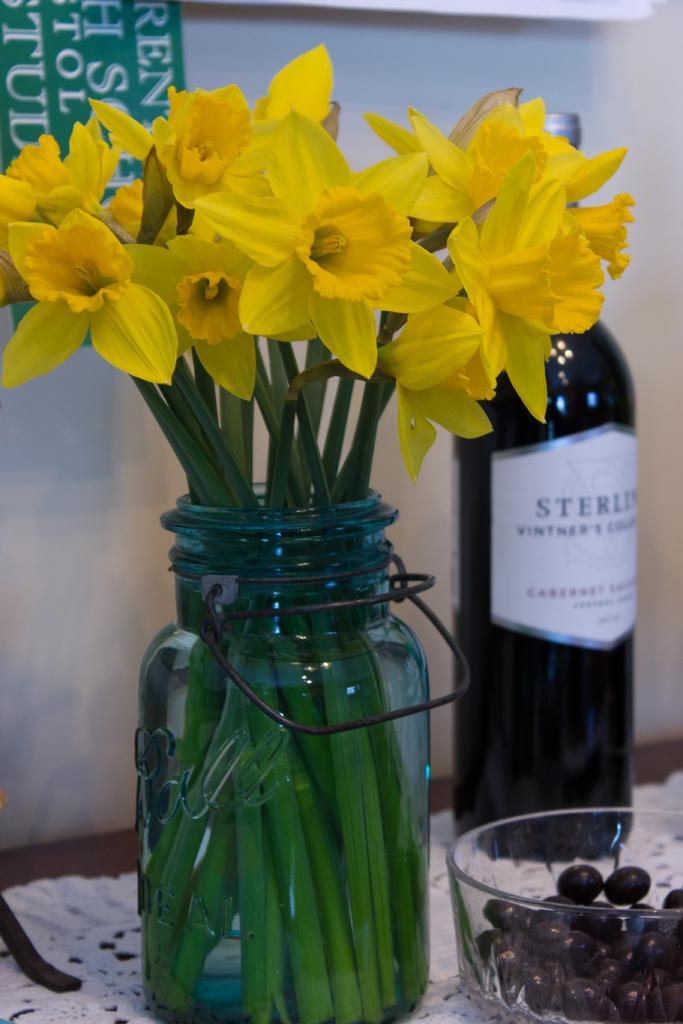Can you describe this image briefly? At the bottom of the image there is a table. There is a bottle, a bowl and a flower vase placed on the table. There is a cloth on the table. In the background there is a wall. 